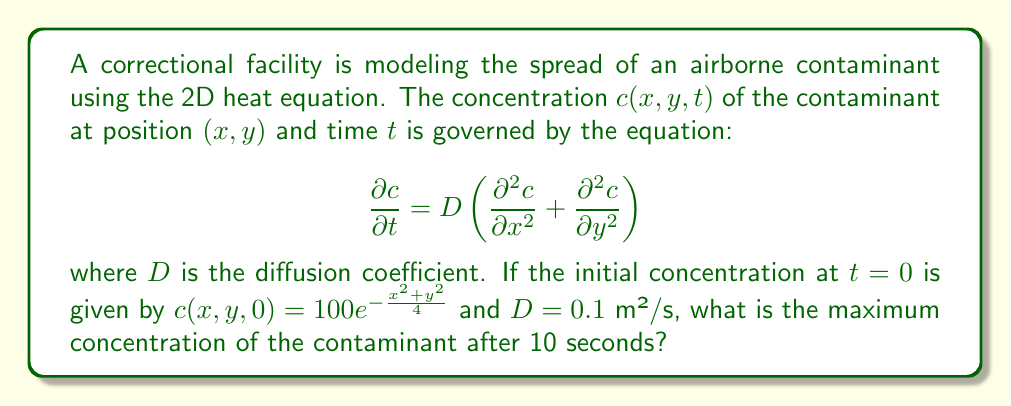Can you solve this math problem? To solve this problem, we need to use the solution of the 2D heat equation with an initial Gaussian distribution. The solution is given by:

$$c(x,y,t) = \frac{M}{4\pi Dt + \sigma^2} e^{-\frac{x^2+y^2}{4Dt + \sigma^2}}$$

where $M$ is the total initial amount of contaminant and $\sigma^2$ is the initial variance of the Gaussian distribution.

Step 1: Identify the initial distribution parameters
From the initial condition, we can see that:
$$ c(x,y,0) = 100e^{-\frac{x^2+y^2}{4}} $$
This means $\sigma^2 = 2$ and $M = 100 \cdot 2\pi = 200\pi$.

Step 2: Substitute the values into the solution equation
$$ c(x,y,t) = \frac{200\pi}{4\pi(0.1)t + 2} e^{-\frac{x^2+y^2}{4(0.1)t + 2}} $$

Step 3: Evaluate at t = 10 seconds
$$ c(x,y,10) = \frac{200\pi}{4\pi(0.1)(10) + 2} e^{-\frac{x^2+y^2}{4(0.1)(10) + 2}} $$
$$ = \frac{200\pi}{4\pi + 2} e^{-\frac{x^2+y^2}{6}} $$

Step 4: Find the maximum concentration
The maximum concentration will occur at the center of the distribution, where $x=0$ and $y=0$. Therefore:

$$ c_{max} = c(0,0,10) = \frac{200\pi}{4\pi + 2} $$

Step 5: Calculate the final result
$$ c_{max} = \frac{200\pi}{4\pi + 2} \approx 47.75 $$
Answer: $47.75$ units of concentration 